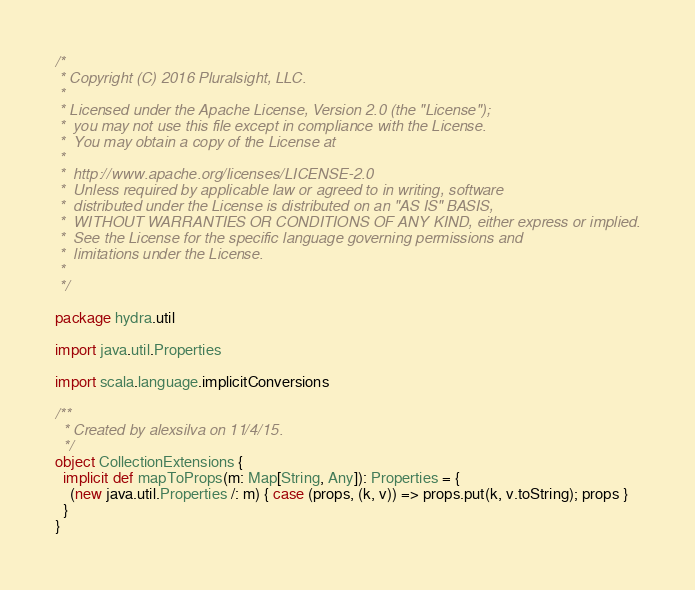Convert code to text. <code><loc_0><loc_0><loc_500><loc_500><_Scala_>/*
 * Copyright (C) 2016 Pluralsight, LLC.
 *
 * Licensed under the Apache License, Version 2.0 (the "License");
 *  you may not use this file except in compliance with the License.
 *  You may obtain a copy of the License at
 *
 *  http://www.apache.org/licenses/LICENSE-2.0
 *  Unless required by applicable law or agreed to in writing, software
 *  distributed under the License is distributed on an "AS IS" BASIS,
 *  WITHOUT WARRANTIES OR CONDITIONS OF ANY KIND, either express or implied.
 *  See the License for the specific language governing permissions and
 *  limitations under the License.
 *
 */

package hydra.util

import java.util.Properties

import scala.language.implicitConversions

/**
  * Created by alexsilva on 11/4/15.
  */
object CollectionExtensions {
  implicit def mapToProps(m: Map[String, Any]): Properties = {
    (new java.util.Properties /: m) { case (props, (k, v)) => props.put(k, v.toString); props }
  }
}
</code> 